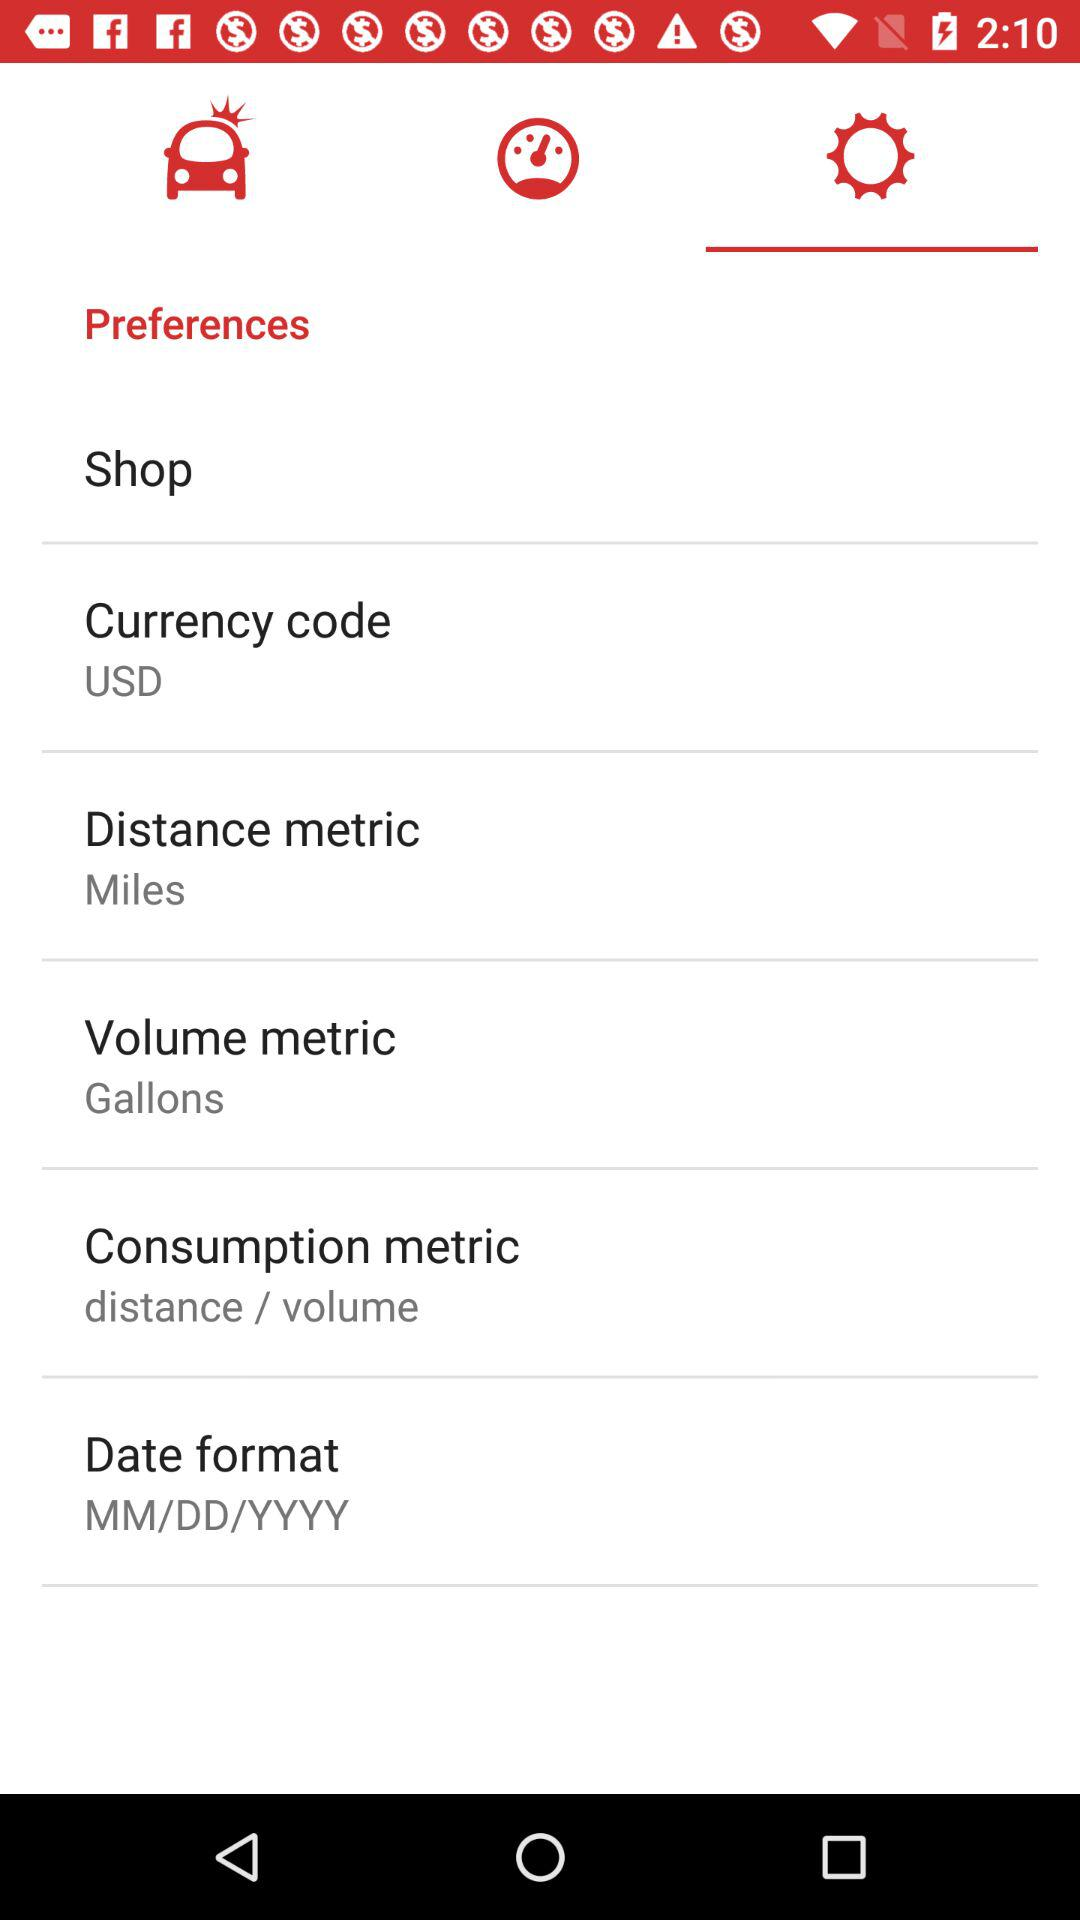What is the given distance metric? The given distance metric is miles. 